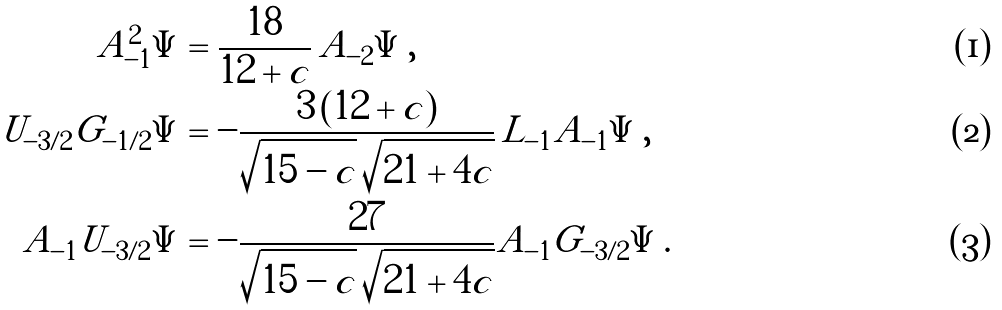<formula> <loc_0><loc_0><loc_500><loc_500>A _ { - 1 } ^ { 2 } \Psi & = \frac { 1 8 } { 1 2 + c } \, A _ { - 2 } \Psi \, , \\ U _ { - 3 / 2 } G _ { - 1 / 2 } \Psi & = - \frac { 3 \, ( 1 2 + c ) } { \sqrt { 1 5 - c } \, \sqrt { 2 1 + 4 c } } \, L _ { - 1 } A _ { - 1 } \Psi \, , \\ A _ { - 1 } U _ { - 3 / 2 } \Psi & = - \frac { 2 7 } { \sqrt { 1 5 - c } \, \sqrt { 2 1 + 4 c } } A _ { - 1 } G _ { - 3 / 2 } \Psi \, .</formula> 